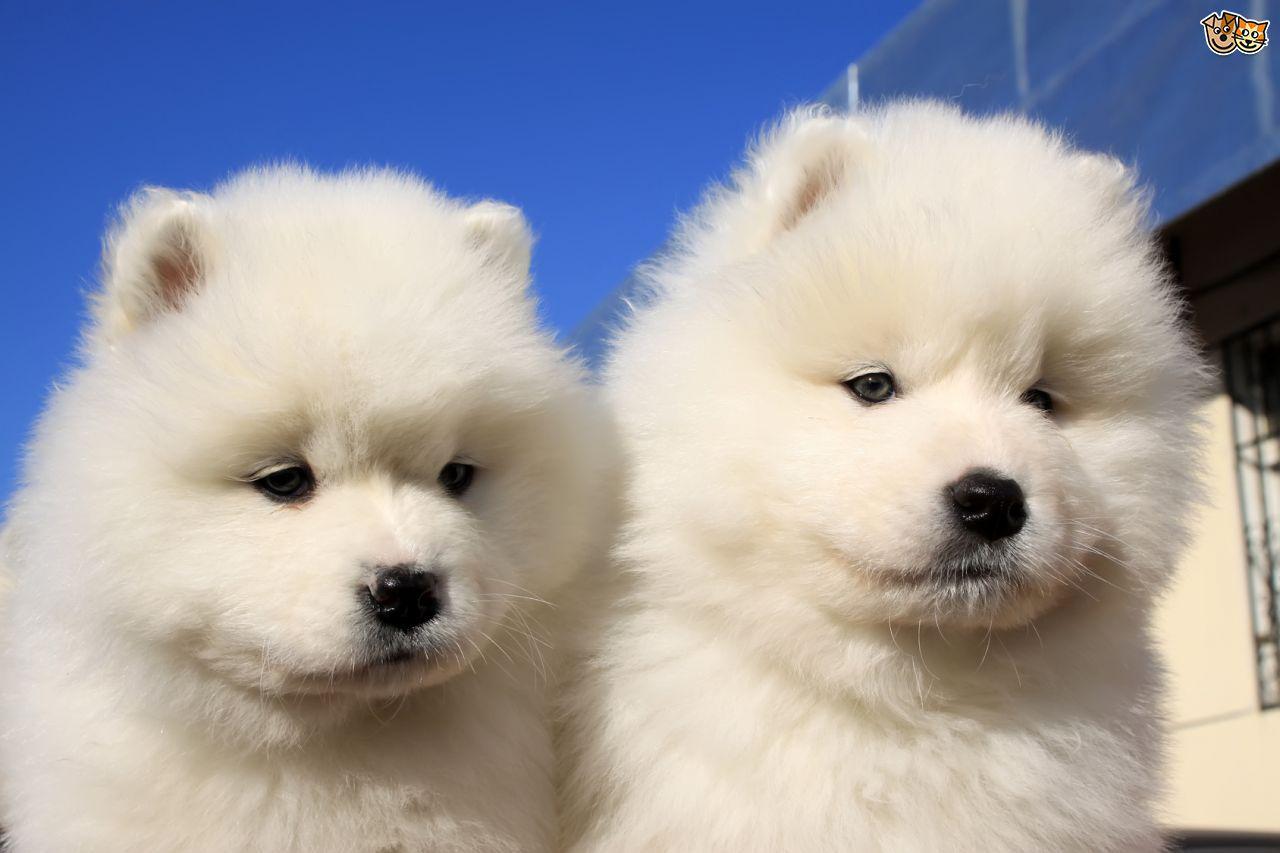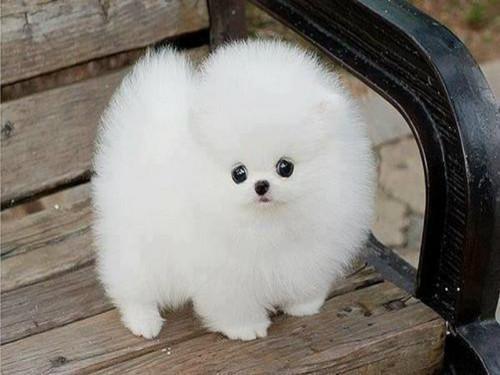The first image is the image on the left, the second image is the image on the right. Analyze the images presented: Is the assertion "There are at least two dogs in the image on the left" valid? Answer yes or no. Yes. The first image is the image on the left, the second image is the image on the right. Examine the images to the left and right. Is the description "One image contains at least two dogs." accurate? Answer yes or no. Yes. 